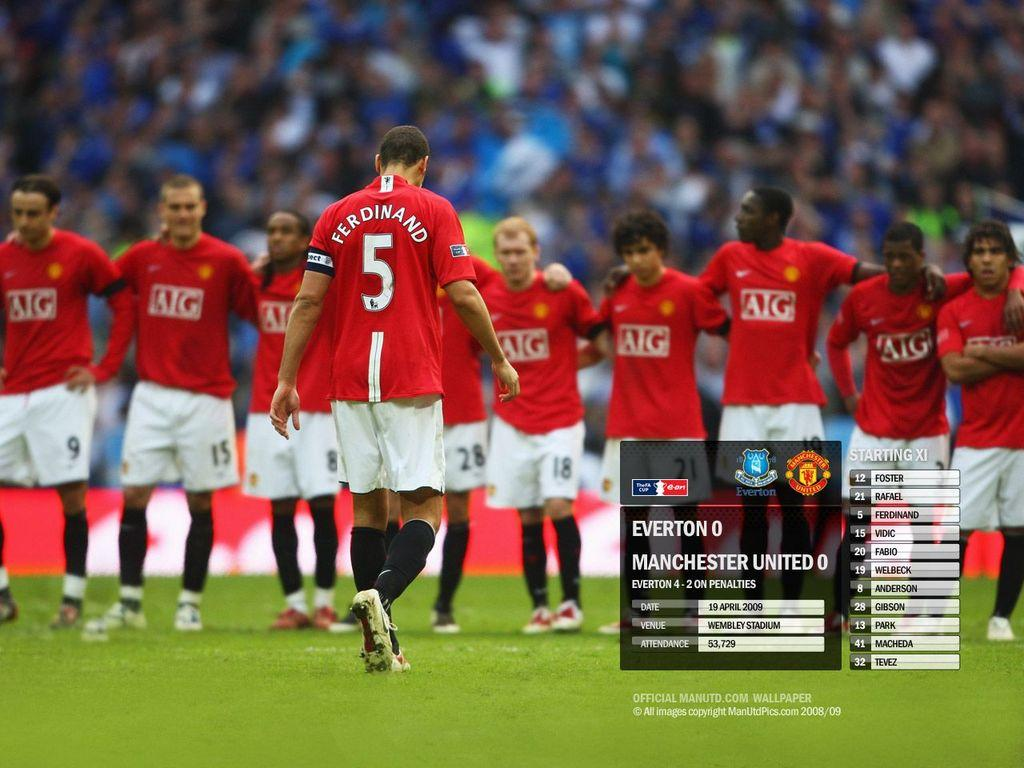Provide a one-sentence caption for the provided image. number 5 soccer player named 'ferdinand' on a field. 